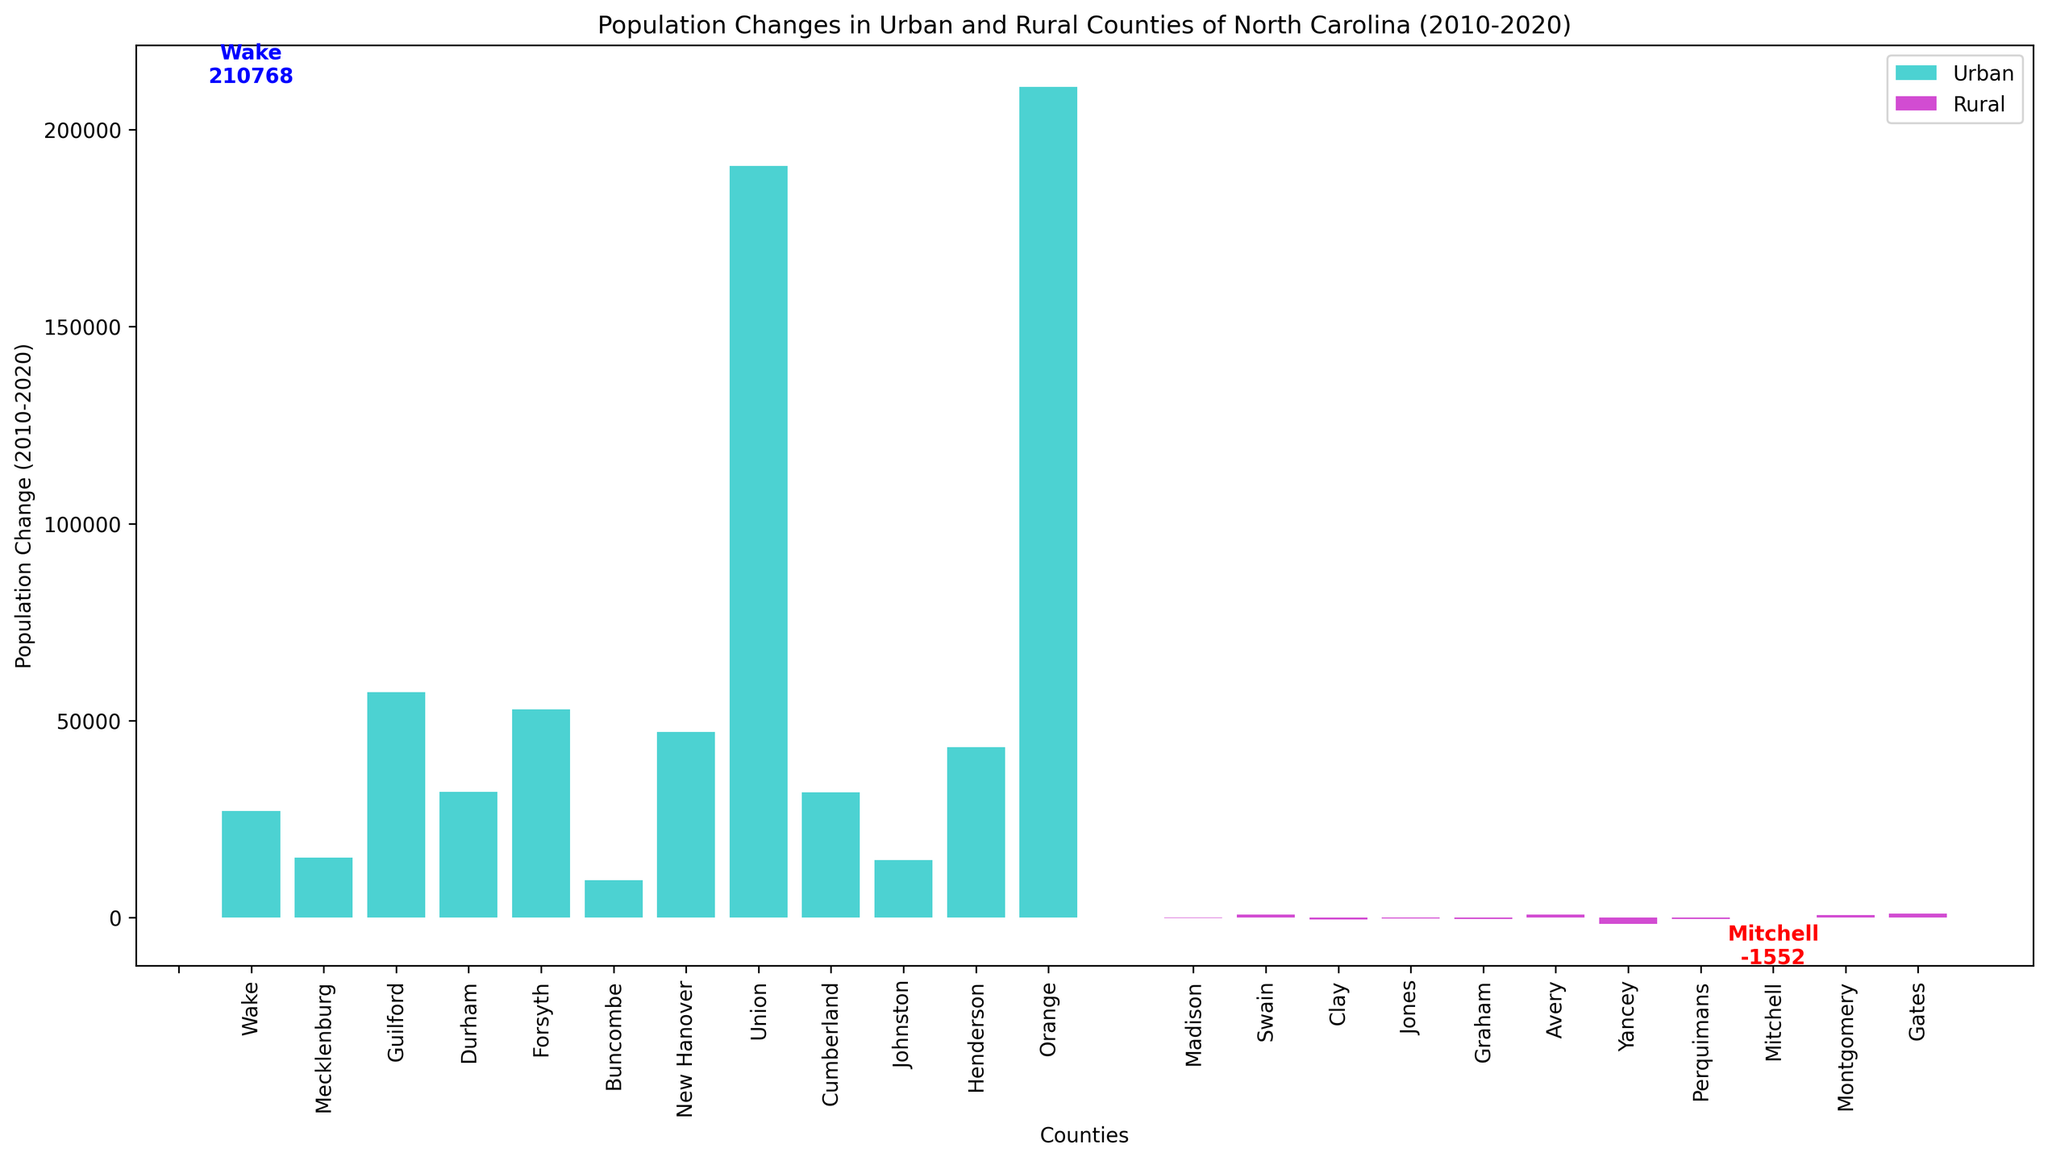What is the county with the highest population increase in urban areas? The bar with the highest value in the urban group (colored in cyan) represents the county with the highest population increase. The annotation on this bar indicates that it is Wake county, with an increase of 211,768.
Answer: Wake Which county experienced the smallest decline in rural population? The bar with the smallest negative value in the rural group (colored in magenta) represents the county with the smallest population decline. The annotation on this bar indicates that it is Graham county, with a decrease of 227.
Answer: Graham What is the total population change across all urban counties from 2010 to 2020? Sum the changes for all urban counties indicated by the heights of the cyan bars. Adding them gives the total population change.
Answer: 603,643 Which urban county had the smallest population change, and what was the change? Identify the shortest bar in the urban group (cyan bars). The smallest change is for Henderson County, with an increase of 9,518.
Answer: Henderson, 9,518 Compare the population change of Forsyth County and Buncombe County in urban areas. Which one had a higher change? Look at the heights of the bars for Forsyth and Buncombe in the urban section (cyan bars). Forsyth's bar is higher than Buncombe's bar, indicating Forsyth had a greater population change.
Answer: Forsyth How many urban counties had a population change greater than 50,000? Count the number of cyan bars that are taller than the value representing 50,000 on the y-axis. Three counties (Wake, Mecklenburg, and Guilford) had changes above 50,000.
Answer: 3 What is the difference in population change between the urban county with the highest increase and the rural county with the smallest decrease? Subtract the value of the smallest decrease in the rural area from the highest increase in the urban area. For Wake's increase (211,768) and Graham's decrease (-227), the difference is 211,768 - (-227) = 211,995.
Answer: 211,995 Which rural county experienced a population increase, and what was the increase? Look for any magenta bars in the rural section that extend above the zero line. Yancey County shows a positive change of 1,081.
Answer: Yancey, 1,081 